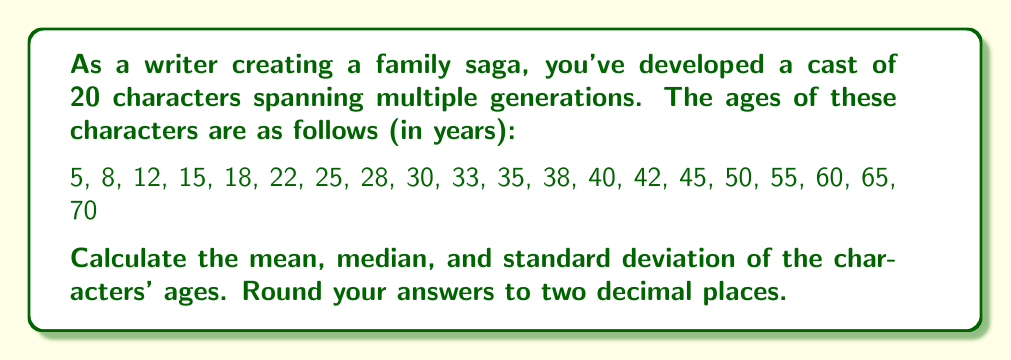Can you answer this question? To analyze the distribution of character ages, we'll calculate the mean, median, and standard deviation.

1. Mean (average):
   $$ \text{Mean} = \frac{\sum_{i=1}^{n} x_i}{n} $$
   where $x_i$ are the individual ages and $n$ is the total number of characters.

   $$ \text{Mean} = \frac{5 + 8 + 12 + ... + 65 + 70}{20} = \frac{596}{20} = 29.80 $$

2. Median:
   With 20 characters, the median is the average of the 10th and 11th values when the ages are arranged in ascending order.
   
   $$ \text{Median} = \frac{33 + 35}{2} = 34 $$

3. Standard Deviation:
   $$ s = \sqrt{\frac{\sum_{i=1}^{n} (x_i - \bar{x})^2}{n - 1}} $$
   where $\bar{x}$ is the mean and $n$ is the number of characters.

   First, calculate the squared differences from the mean:
   $$ (5 - 29.80)^2 + (8 - 29.80)^2 + ... + (70 - 29.80)^2 $$

   Sum these squared differences:
   $$ \sum_{i=1}^{n} (x_i - \bar{x})^2 = 8456.80 $$

   Now, apply the formula:
   $$ s = \sqrt{\frac{8456.80}{19}} = \sqrt{445.09} = 21.10 $$
Answer: Mean: 29.80 years
Median: 34.00 years
Standard Deviation: 21.10 years 